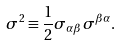Convert formula to latex. <formula><loc_0><loc_0><loc_500><loc_500>\sigma ^ { 2 } \equiv \frac { 1 } { 2 } \sigma _ { \alpha \beta } \sigma ^ { \beta \alpha } .</formula> 